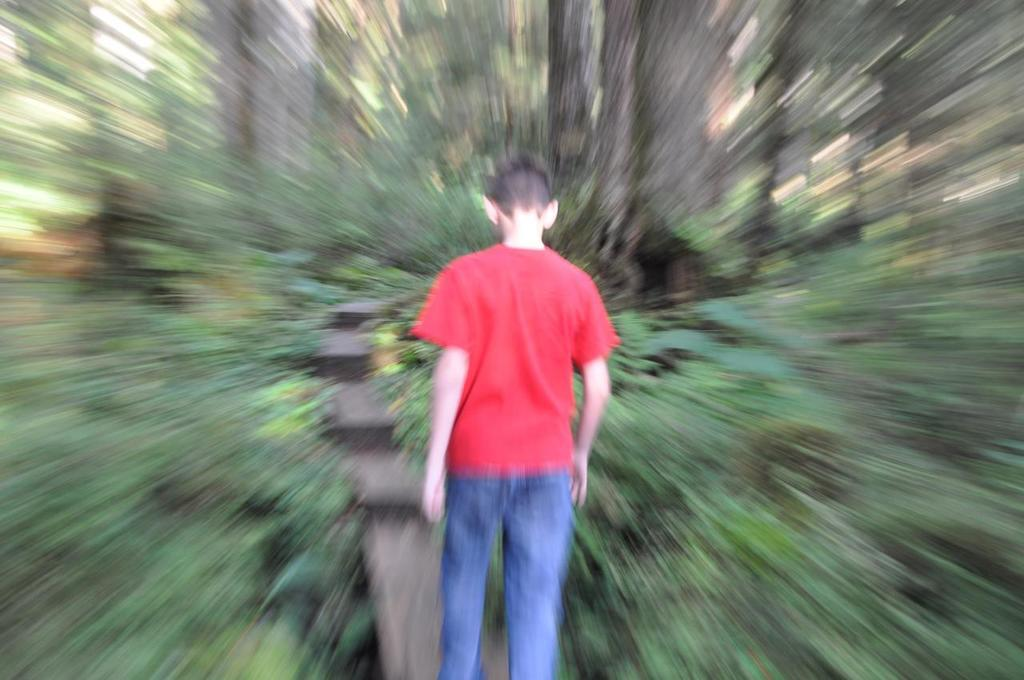What can be observed about the image's appearance? The image is edited. Who or what is present in the image? There is a person in the image. What is the person doing in the image? The person is turning backwards. How is the area around the person depicted in the image? The portion around the person is blurred. Is the person wearing a mask in the image? There is no mention of a mask in the image, so it cannot be determined from the provided facts. 